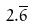Convert formula to latex. <formula><loc_0><loc_0><loc_500><loc_500>2 . \overline { 6 }</formula> 